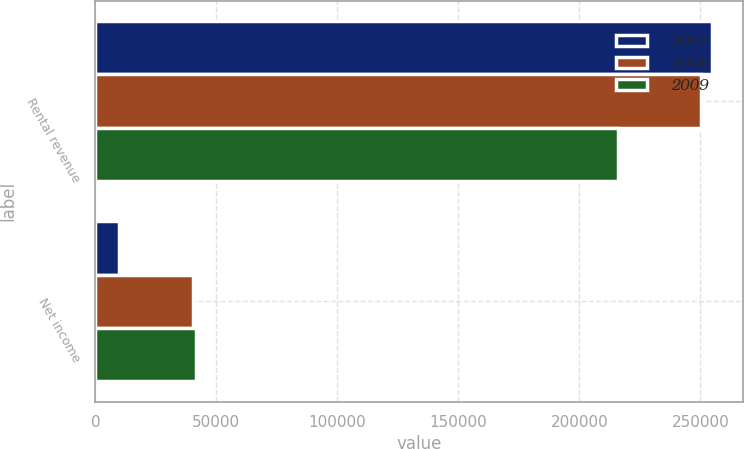<chart> <loc_0><loc_0><loc_500><loc_500><stacked_bar_chart><ecel><fcel>Rental revenue<fcel>Net income<nl><fcel>2007<fcel>254787<fcel>9760<nl><fcel>2008<fcel>250312<fcel>40437<nl><fcel>2009<fcel>215855<fcel>41725<nl></chart> 